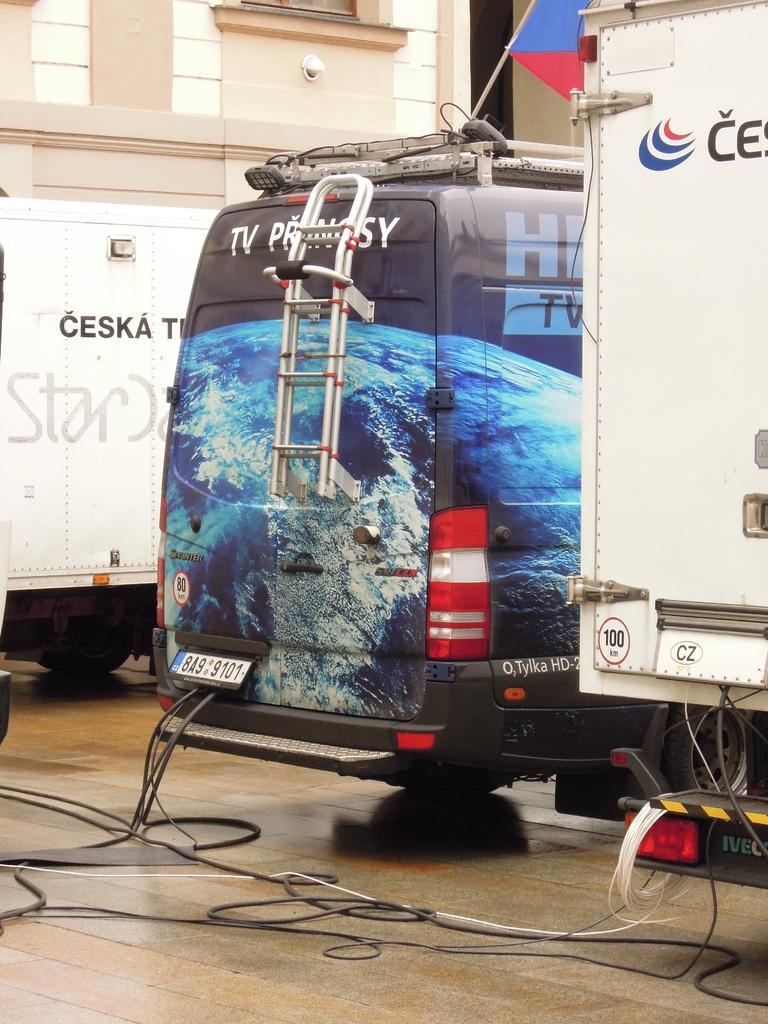In one or two sentences, can you explain what this image depicts? In this image, we can see few vehicles are on the platform. Here we can see some wires. Background there is a building, flag with rod. 